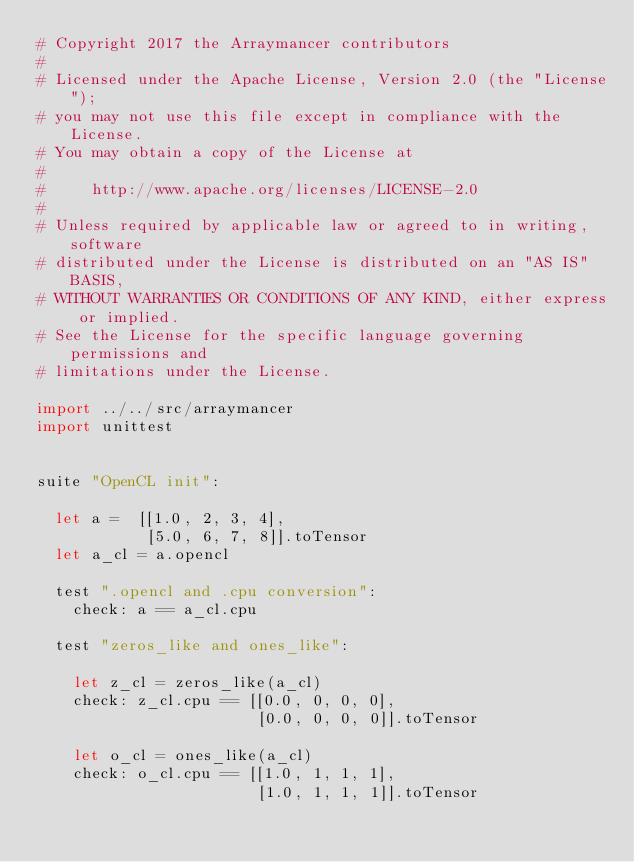<code> <loc_0><loc_0><loc_500><loc_500><_Nim_># Copyright 2017 the Arraymancer contributors
#
# Licensed under the Apache License, Version 2.0 (the "License");
# you may not use this file except in compliance with the License.
# You may obtain a copy of the License at
#
#     http://www.apache.org/licenses/LICENSE-2.0
#
# Unless required by applicable law or agreed to in writing, software
# distributed under the License is distributed on an "AS IS" BASIS,
# WITHOUT WARRANTIES OR CONDITIONS OF ANY KIND, either express or implied.
# See the License for the specific language governing permissions and
# limitations under the License.

import ../../src/arraymancer
import unittest


suite "OpenCL init":

  let a =  [[1.0, 2, 3, 4],
            [5.0, 6, 7, 8]].toTensor
  let a_cl = a.opencl

  test ".opencl and .cpu conversion":
    check: a == a_cl.cpu

  test "zeros_like and ones_like":

    let z_cl = zeros_like(a_cl)
    check: z_cl.cpu == [[0.0, 0, 0, 0],
                        [0.0, 0, 0, 0]].toTensor

    let o_cl = ones_like(a_cl)
    check: o_cl.cpu == [[1.0, 1, 1, 1],
                        [1.0, 1, 1, 1]].toTensor</code> 